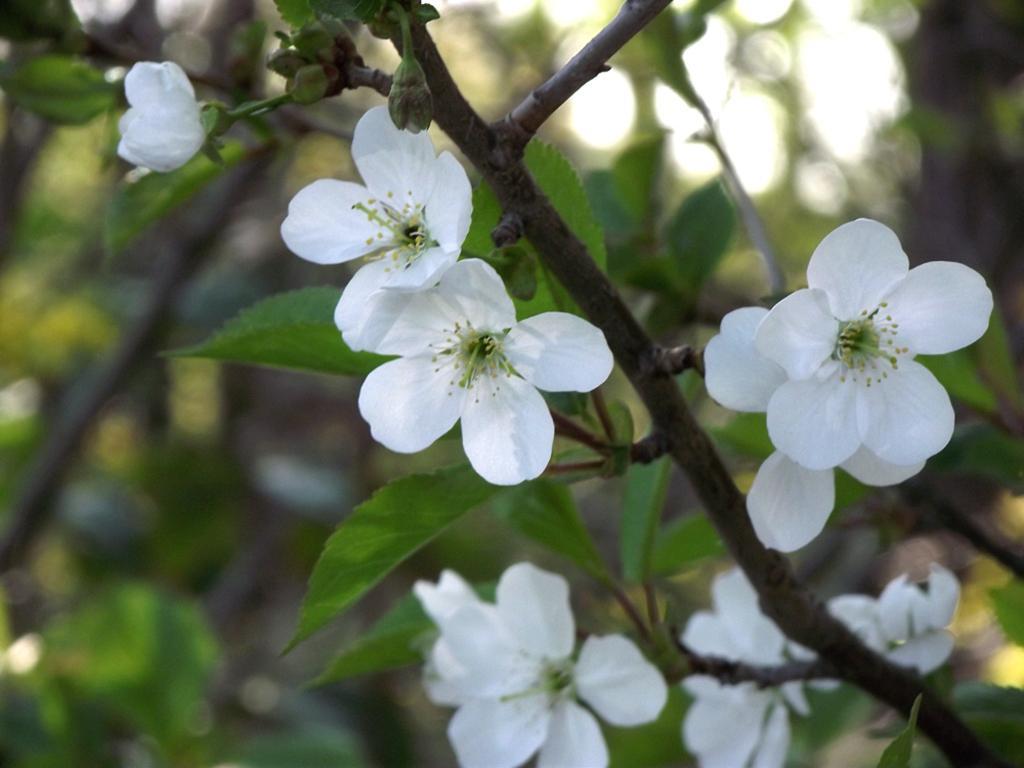What type of plant is depicted in the image? There are white flowers in the image. What other parts of the plant can be seen besides the flowers? Leaves and stems are visible in the image. How would you describe the background of the image? The background has a blurred view. How many hands are holding the flowers in the image? There are no hands visible in the image; it only shows the flowers, leaves, and stems. Can you spot an ant crawling on the leaves in the image? There is no ant present in the image. 